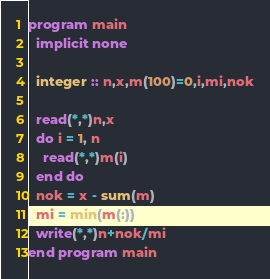<code> <loc_0><loc_0><loc_500><loc_500><_FORTRAN_>program main
  implicit none
  
  integer :: n,x,m(100)=0,i,mi,nok
  
  read(*,*)n,x
  do i = 1, n
    read(*,*)m(i)
  end do
  nok = x - sum(m)
  mi = min(m(:))
  write(*,*)n+nok/mi
end program main</code> 